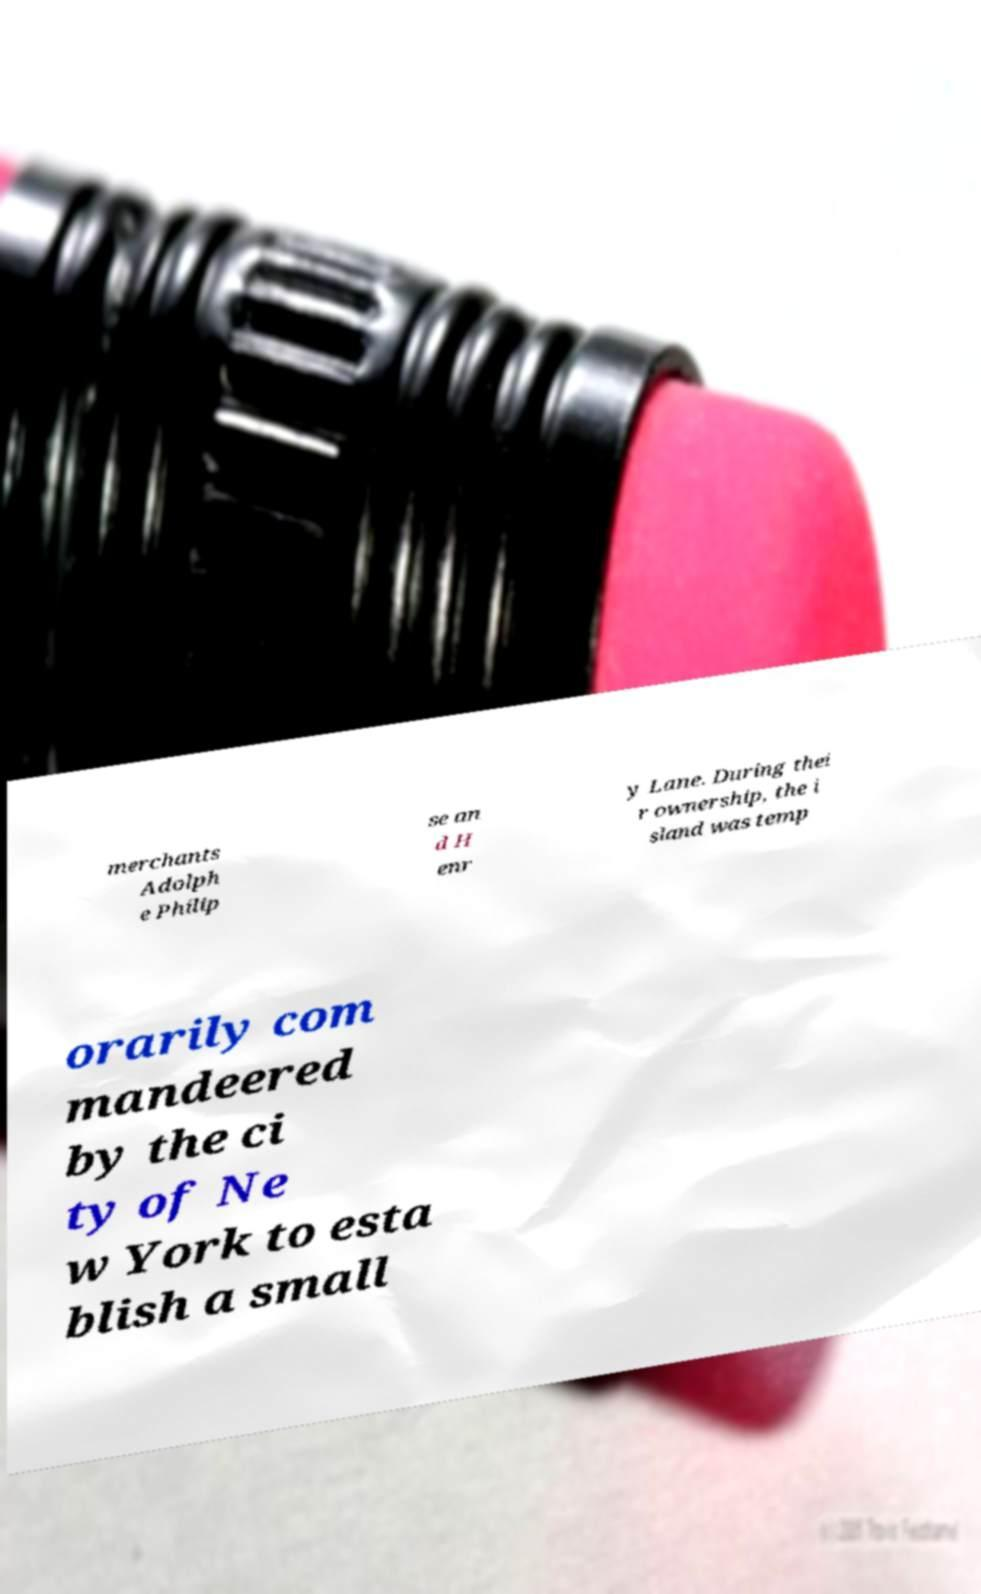Could you assist in decoding the text presented in this image and type it out clearly? merchants Adolph e Philip se an d H enr y Lane. During thei r ownership, the i sland was temp orarily com mandeered by the ci ty of Ne w York to esta blish a small 